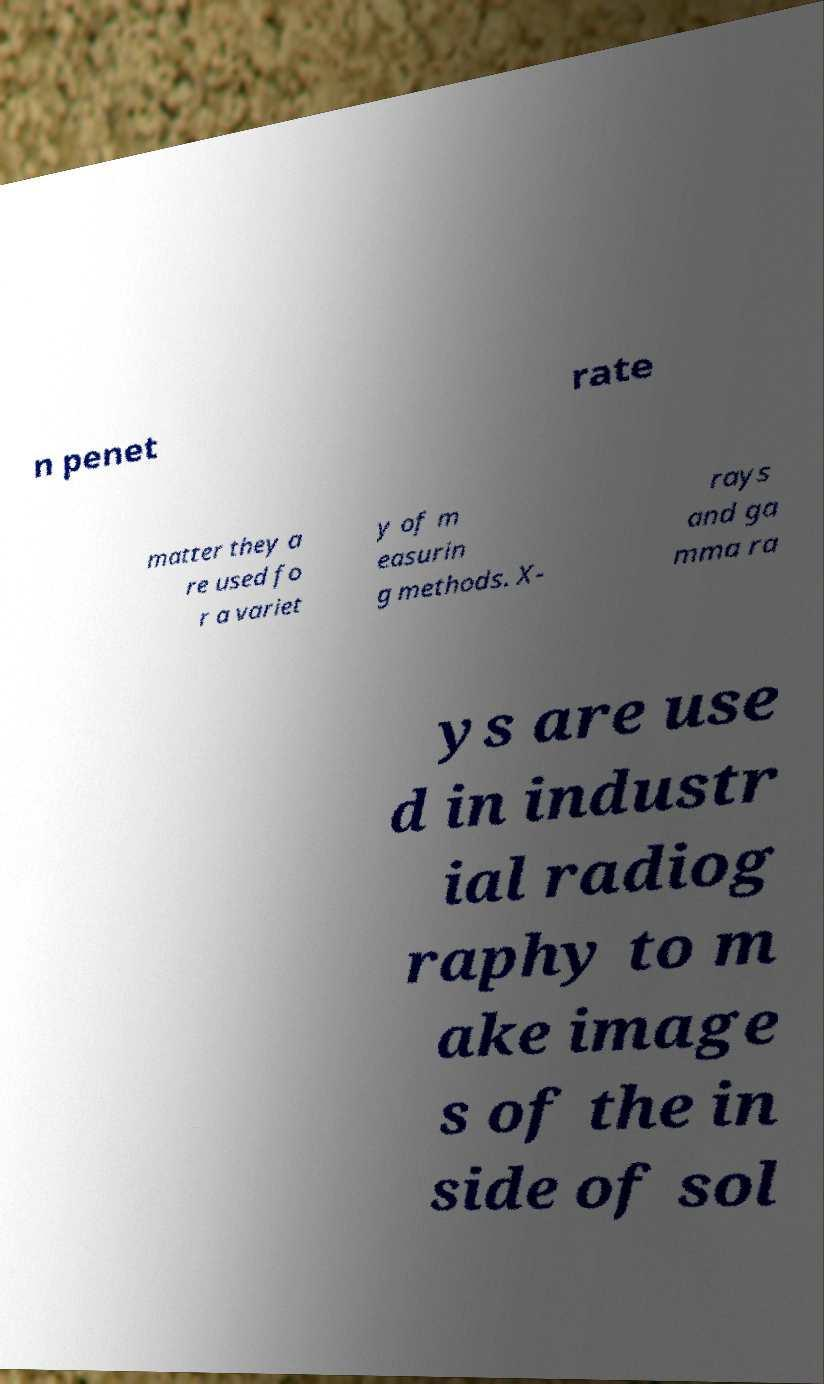There's text embedded in this image that I need extracted. Can you transcribe it verbatim? n penet rate matter they a re used fo r a variet y of m easurin g methods. X- rays and ga mma ra ys are use d in industr ial radiog raphy to m ake image s of the in side of sol 